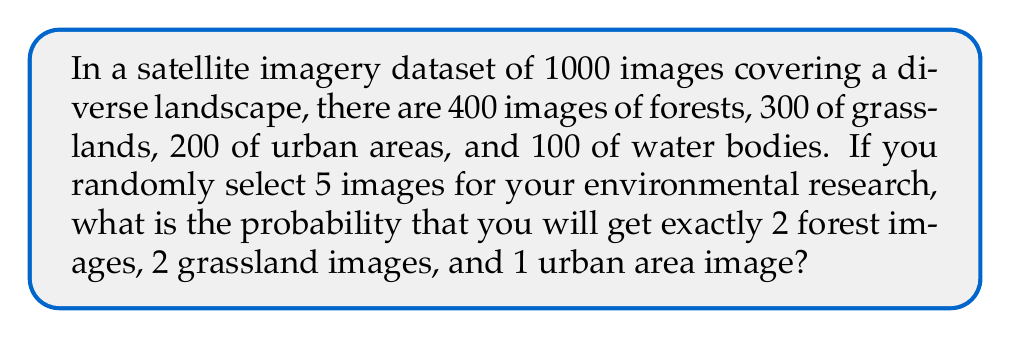Help me with this question. To solve this problem, we need to use the concept of hypergeometric distribution, which is applicable when sampling without replacement from a finite population.

Let's break down the problem step by step:

1) First, we need to calculate the number of ways to select 2 forest images out of 400:
   $$\binom{400}{2}$$

2) Then, we calculate the number of ways to select 2 grassland images out of 300:
   $$\binom{300}{2}$$

3) Next, we calculate the number of ways to select 1 urban area image out of 200:
   $$\binom{200}{1}$$

4) Now, we multiply these together to get the number of favorable outcomes:
   $$\binom{400}{2} \cdot \binom{300}{2} \cdot \binom{200}{1}$$

5) The total number of ways to select 5 images out of 1000 is:
   $$\binom{1000}{5}$$

6) The probability is then the number of favorable outcomes divided by the total number of possible outcomes:

   $$P = \frac{\binom{400}{2} \cdot \binom{300}{2} \cdot \binom{200}{1}}{\binom{1000}{5}}$$

7) Let's calculate each part:
   $$\binom{400}{2} = 79800$$
   $$\binom{300}{2} = 44850$$
   $$\binom{200}{1} = 200$$
   $$\binom{1000}{5} = 8250083755$$

8) Substituting these values:

   $$P = \frac{79800 \cdot 44850 \cdot 200}{8250083755} \approx 0.008631$$
Answer: The probability is approximately 0.008631 or about 0.8631%. 